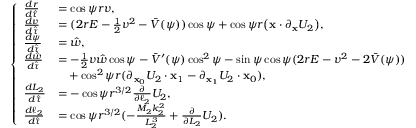Convert formula to latex. <formula><loc_0><loc_0><loc_500><loc_500>\left \{ \begin{array} { l l } { \frac { d r } { d \hat { \tau } } } & { = \cos \psi r v , } \\ { \frac { d v } { d \hat { \tau } } } & { = ( 2 r E - \frac { 1 } { 2 } v ^ { 2 } - \bar { V } ( \psi ) ) \cos \psi + \cos \psi r \left ( x \cdot \partial _ { x } U _ { 2 } \right ) , } \\ { \frac { d \psi } { d \hat { \tau } } } & { = \hat { w } , } \\ { \frac { d \hat { w } } { d \hat { \tau } } } & { = - \frac { 1 } { 2 } v \hat { w } \cos \psi - \bar { V } ^ { \prime } ( \psi ) \cos ^ { 2 } \psi - \sin \psi \cos \psi ( 2 r E - v ^ { 2 } - 2 \bar { V } ( \psi ) ) } \\ & { \quad + \cos ^ { 2 } \psi r ( \partial _ { x _ { 0 } } U _ { 2 } \cdot x _ { 1 } - \partial _ { x _ { 1 } } U _ { 2 } \cdot x _ { 0 } ) , } \\ { \frac { d L _ { 2 } } { d \hat { \tau } } } & { = - \cos \psi r ^ { 3 / 2 } \frac { \partial } { \partial \ell _ { 2 } } U _ { 2 } , } \\ { \frac { d \ell _ { 2 } } { d \hat { \tau } } } & { = \cos \psi r ^ { 3 / 2 } ( - \frac { M _ { 2 } k _ { 2 } ^ { 2 } } { L _ { 2 } ^ { 3 } } + \frac { \partial } { \partial L _ { 2 } } U _ { 2 } ) . } \end{array}</formula> 